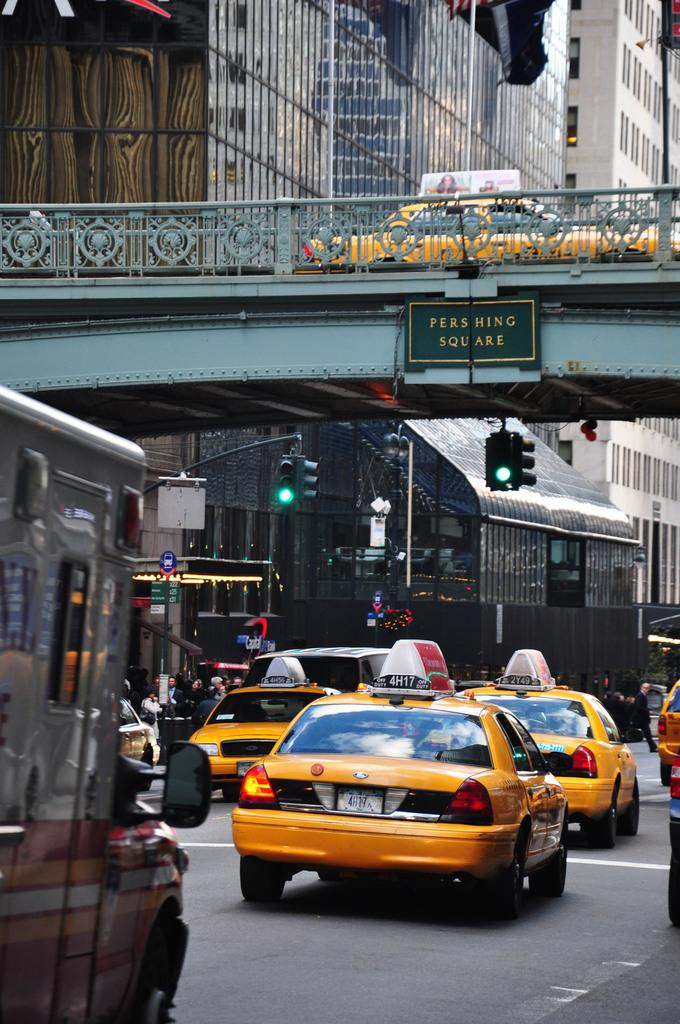<image>
Render a clear and concise summary of the photo. a sign above the street on a bridge that says pershing square 